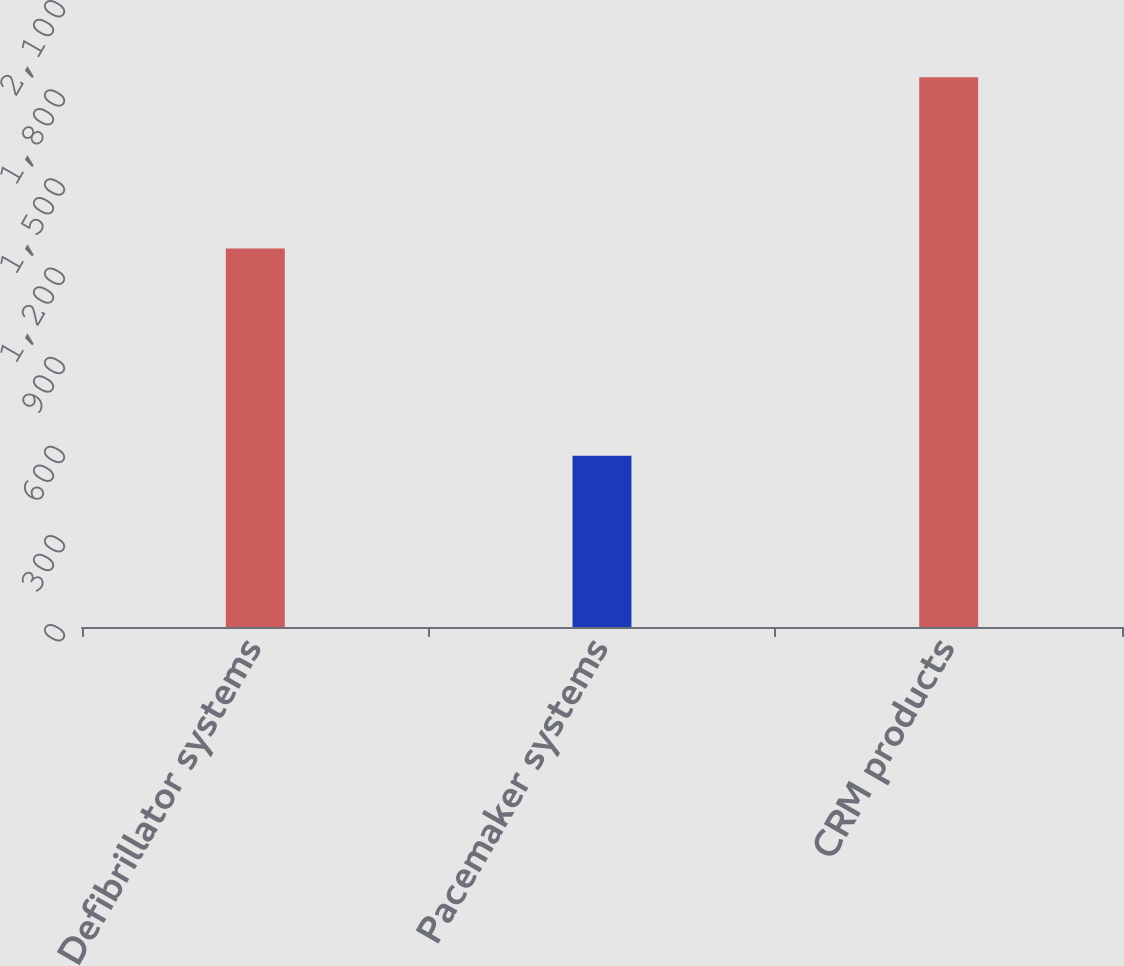Convert chart to OTSL. <chart><loc_0><loc_0><loc_500><loc_500><bar_chart><fcel>Defibrillator systems<fcel>Pacemaker systems<fcel>CRM products<nl><fcel>1274<fcel>576<fcel>1850<nl></chart> 